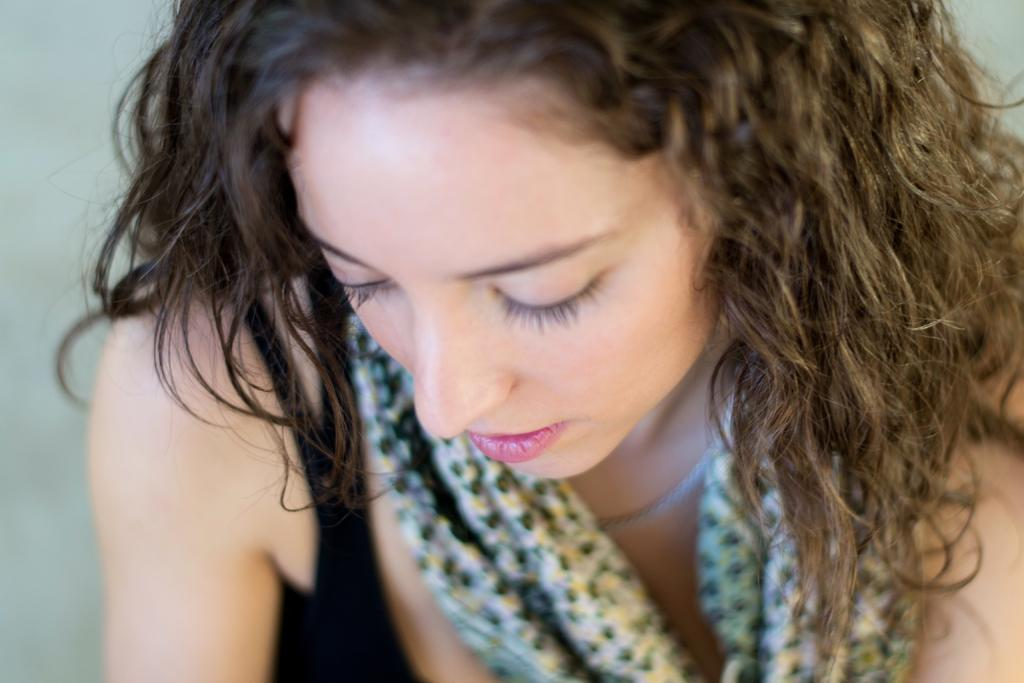Who is the main subject in the image? There is a woman in the image. What is the woman wearing? The woman is wearing a black top. Can you describe the quality of the image? The image is slightly blurry. What type of horn can be heard in the image? There is no horn or sound present in the image, as it is a still photograph. 